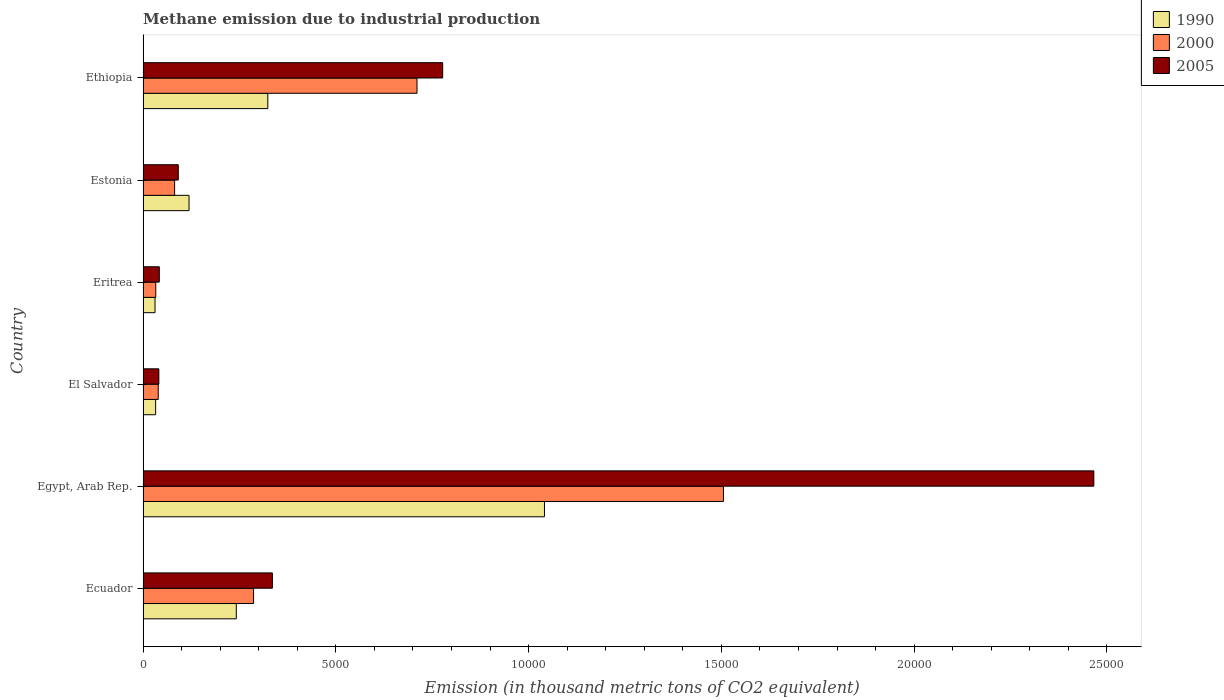How many different coloured bars are there?
Offer a very short reply. 3. Are the number of bars per tick equal to the number of legend labels?
Make the answer very short. Yes. Are the number of bars on each tick of the Y-axis equal?
Make the answer very short. Yes. How many bars are there on the 6th tick from the top?
Provide a short and direct response. 3. What is the label of the 6th group of bars from the top?
Offer a terse response. Ecuador. What is the amount of methane emitted in 2000 in Ethiopia?
Make the answer very short. 7106. Across all countries, what is the maximum amount of methane emitted in 2005?
Provide a succinct answer. 2.47e+04. Across all countries, what is the minimum amount of methane emitted in 2000?
Ensure brevity in your answer.  329.4. In which country was the amount of methane emitted in 2000 maximum?
Your response must be concise. Egypt, Arab Rep. In which country was the amount of methane emitted in 1990 minimum?
Offer a very short reply. Eritrea. What is the total amount of methane emitted in 2000 in the graph?
Offer a terse response. 2.66e+04. What is the difference between the amount of methane emitted in 2000 in Ecuador and that in Estonia?
Keep it short and to the point. 2047.9. What is the difference between the amount of methane emitted in 1990 in Eritrea and the amount of methane emitted in 2005 in Egypt, Arab Rep.?
Your response must be concise. -2.44e+04. What is the average amount of methane emitted in 1990 per country?
Offer a very short reply. 2982.55. What is the difference between the amount of methane emitted in 2000 and amount of methane emitted in 2005 in Egypt, Arab Rep.?
Offer a very short reply. -9607. What is the ratio of the amount of methane emitted in 2000 in El Salvador to that in Ethiopia?
Your answer should be very brief. 0.06. What is the difference between the highest and the second highest amount of methane emitted in 2005?
Make the answer very short. 1.69e+04. What is the difference between the highest and the lowest amount of methane emitted in 2000?
Your answer should be compact. 1.47e+04. What does the 3rd bar from the top in Eritrea represents?
Your response must be concise. 1990. What does the 3rd bar from the bottom in Ethiopia represents?
Ensure brevity in your answer.  2005. How many bars are there?
Your response must be concise. 18. Are all the bars in the graph horizontal?
Keep it short and to the point. Yes. How many countries are there in the graph?
Offer a very short reply. 6. Where does the legend appear in the graph?
Offer a terse response. Top right. How many legend labels are there?
Offer a terse response. 3. What is the title of the graph?
Your answer should be compact. Methane emission due to industrial production. Does "1973" appear as one of the legend labels in the graph?
Your answer should be compact. No. What is the label or title of the X-axis?
Provide a short and direct response. Emission (in thousand metric tons of CO2 equivalent). What is the label or title of the Y-axis?
Your answer should be compact. Country. What is the Emission (in thousand metric tons of CO2 equivalent) of 1990 in Ecuador?
Your response must be concise. 2418.4. What is the Emission (in thousand metric tons of CO2 equivalent) of 2000 in Ecuador?
Offer a terse response. 2866.1. What is the Emission (in thousand metric tons of CO2 equivalent) in 2005 in Ecuador?
Your response must be concise. 3354.7. What is the Emission (in thousand metric tons of CO2 equivalent) in 1990 in Egypt, Arab Rep.?
Your answer should be compact. 1.04e+04. What is the Emission (in thousand metric tons of CO2 equivalent) of 2000 in Egypt, Arab Rep.?
Give a very brief answer. 1.51e+04. What is the Emission (in thousand metric tons of CO2 equivalent) in 2005 in Egypt, Arab Rep.?
Your answer should be very brief. 2.47e+04. What is the Emission (in thousand metric tons of CO2 equivalent) of 1990 in El Salvador?
Make the answer very short. 325.8. What is the Emission (in thousand metric tons of CO2 equivalent) of 2000 in El Salvador?
Your answer should be very brief. 393.6. What is the Emission (in thousand metric tons of CO2 equivalent) in 2005 in El Salvador?
Provide a succinct answer. 409.3. What is the Emission (in thousand metric tons of CO2 equivalent) of 1990 in Eritrea?
Provide a short and direct response. 310.4. What is the Emission (in thousand metric tons of CO2 equivalent) of 2000 in Eritrea?
Offer a terse response. 329.4. What is the Emission (in thousand metric tons of CO2 equivalent) in 2005 in Eritrea?
Keep it short and to the point. 421.4. What is the Emission (in thousand metric tons of CO2 equivalent) in 1990 in Estonia?
Give a very brief answer. 1192.7. What is the Emission (in thousand metric tons of CO2 equivalent) in 2000 in Estonia?
Give a very brief answer. 818.2. What is the Emission (in thousand metric tons of CO2 equivalent) in 2005 in Estonia?
Your answer should be very brief. 913.5. What is the Emission (in thousand metric tons of CO2 equivalent) in 1990 in Ethiopia?
Your answer should be very brief. 3236. What is the Emission (in thousand metric tons of CO2 equivalent) of 2000 in Ethiopia?
Your answer should be compact. 7106. What is the Emission (in thousand metric tons of CO2 equivalent) of 2005 in Ethiopia?
Your response must be concise. 7772.1. Across all countries, what is the maximum Emission (in thousand metric tons of CO2 equivalent) in 1990?
Provide a short and direct response. 1.04e+04. Across all countries, what is the maximum Emission (in thousand metric tons of CO2 equivalent) in 2000?
Ensure brevity in your answer.  1.51e+04. Across all countries, what is the maximum Emission (in thousand metric tons of CO2 equivalent) in 2005?
Offer a very short reply. 2.47e+04. Across all countries, what is the minimum Emission (in thousand metric tons of CO2 equivalent) of 1990?
Give a very brief answer. 310.4. Across all countries, what is the minimum Emission (in thousand metric tons of CO2 equivalent) of 2000?
Your response must be concise. 329.4. Across all countries, what is the minimum Emission (in thousand metric tons of CO2 equivalent) of 2005?
Provide a short and direct response. 409.3. What is the total Emission (in thousand metric tons of CO2 equivalent) in 1990 in the graph?
Provide a succinct answer. 1.79e+04. What is the total Emission (in thousand metric tons of CO2 equivalent) in 2000 in the graph?
Keep it short and to the point. 2.66e+04. What is the total Emission (in thousand metric tons of CO2 equivalent) of 2005 in the graph?
Your answer should be very brief. 3.75e+04. What is the difference between the Emission (in thousand metric tons of CO2 equivalent) of 1990 in Ecuador and that in Egypt, Arab Rep.?
Offer a terse response. -7993.6. What is the difference between the Emission (in thousand metric tons of CO2 equivalent) of 2000 in Ecuador and that in Egypt, Arab Rep.?
Your answer should be compact. -1.22e+04. What is the difference between the Emission (in thousand metric tons of CO2 equivalent) of 2005 in Ecuador and that in Egypt, Arab Rep.?
Make the answer very short. -2.13e+04. What is the difference between the Emission (in thousand metric tons of CO2 equivalent) of 1990 in Ecuador and that in El Salvador?
Offer a very short reply. 2092.6. What is the difference between the Emission (in thousand metric tons of CO2 equivalent) of 2000 in Ecuador and that in El Salvador?
Your answer should be compact. 2472.5. What is the difference between the Emission (in thousand metric tons of CO2 equivalent) in 2005 in Ecuador and that in El Salvador?
Keep it short and to the point. 2945.4. What is the difference between the Emission (in thousand metric tons of CO2 equivalent) of 1990 in Ecuador and that in Eritrea?
Keep it short and to the point. 2108. What is the difference between the Emission (in thousand metric tons of CO2 equivalent) of 2000 in Ecuador and that in Eritrea?
Keep it short and to the point. 2536.7. What is the difference between the Emission (in thousand metric tons of CO2 equivalent) in 2005 in Ecuador and that in Eritrea?
Your response must be concise. 2933.3. What is the difference between the Emission (in thousand metric tons of CO2 equivalent) in 1990 in Ecuador and that in Estonia?
Your answer should be very brief. 1225.7. What is the difference between the Emission (in thousand metric tons of CO2 equivalent) in 2000 in Ecuador and that in Estonia?
Provide a succinct answer. 2047.9. What is the difference between the Emission (in thousand metric tons of CO2 equivalent) in 2005 in Ecuador and that in Estonia?
Ensure brevity in your answer.  2441.2. What is the difference between the Emission (in thousand metric tons of CO2 equivalent) in 1990 in Ecuador and that in Ethiopia?
Your answer should be very brief. -817.6. What is the difference between the Emission (in thousand metric tons of CO2 equivalent) in 2000 in Ecuador and that in Ethiopia?
Offer a very short reply. -4239.9. What is the difference between the Emission (in thousand metric tons of CO2 equivalent) in 2005 in Ecuador and that in Ethiopia?
Your answer should be compact. -4417.4. What is the difference between the Emission (in thousand metric tons of CO2 equivalent) of 1990 in Egypt, Arab Rep. and that in El Salvador?
Your answer should be very brief. 1.01e+04. What is the difference between the Emission (in thousand metric tons of CO2 equivalent) of 2000 in Egypt, Arab Rep. and that in El Salvador?
Your response must be concise. 1.47e+04. What is the difference between the Emission (in thousand metric tons of CO2 equivalent) of 2005 in Egypt, Arab Rep. and that in El Salvador?
Your answer should be very brief. 2.43e+04. What is the difference between the Emission (in thousand metric tons of CO2 equivalent) in 1990 in Egypt, Arab Rep. and that in Eritrea?
Keep it short and to the point. 1.01e+04. What is the difference between the Emission (in thousand metric tons of CO2 equivalent) in 2000 in Egypt, Arab Rep. and that in Eritrea?
Ensure brevity in your answer.  1.47e+04. What is the difference between the Emission (in thousand metric tons of CO2 equivalent) of 2005 in Egypt, Arab Rep. and that in Eritrea?
Your answer should be very brief. 2.42e+04. What is the difference between the Emission (in thousand metric tons of CO2 equivalent) in 1990 in Egypt, Arab Rep. and that in Estonia?
Offer a very short reply. 9219.3. What is the difference between the Emission (in thousand metric tons of CO2 equivalent) in 2000 in Egypt, Arab Rep. and that in Estonia?
Your answer should be compact. 1.42e+04. What is the difference between the Emission (in thousand metric tons of CO2 equivalent) of 2005 in Egypt, Arab Rep. and that in Estonia?
Give a very brief answer. 2.37e+04. What is the difference between the Emission (in thousand metric tons of CO2 equivalent) in 1990 in Egypt, Arab Rep. and that in Ethiopia?
Ensure brevity in your answer.  7176. What is the difference between the Emission (in thousand metric tons of CO2 equivalent) in 2000 in Egypt, Arab Rep. and that in Ethiopia?
Your answer should be compact. 7948.9. What is the difference between the Emission (in thousand metric tons of CO2 equivalent) of 2005 in Egypt, Arab Rep. and that in Ethiopia?
Your response must be concise. 1.69e+04. What is the difference between the Emission (in thousand metric tons of CO2 equivalent) of 2000 in El Salvador and that in Eritrea?
Your answer should be compact. 64.2. What is the difference between the Emission (in thousand metric tons of CO2 equivalent) in 2005 in El Salvador and that in Eritrea?
Keep it short and to the point. -12.1. What is the difference between the Emission (in thousand metric tons of CO2 equivalent) of 1990 in El Salvador and that in Estonia?
Your response must be concise. -866.9. What is the difference between the Emission (in thousand metric tons of CO2 equivalent) in 2000 in El Salvador and that in Estonia?
Your answer should be very brief. -424.6. What is the difference between the Emission (in thousand metric tons of CO2 equivalent) of 2005 in El Salvador and that in Estonia?
Provide a short and direct response. -504.2. What is the difference between the Emission (in thousand metric tons of CO2 equivalent) of 1990 in El Salvador and that in Ethiopia?
Ensure brevity in your answer.  -2910.2. What is the difference between the Emission (in thousand metric tons of CO2 equivalent) of 2000 in El Salvador and that in Ethiopia?
Ensure brevity in your answer.  -6712.4. What is the difference between the Emission (in thousand metric tons of CO2 equivalent) of 2005 in El Salvador and that in Ethiopia?
Make the answer very short. -7362.8. What is the difference between the Emission (in thousand metric tons of CO2 equivalent) of 1990 in Eritrea and that in Estonia?
Your response must be concise. -882.3. What is the difference between the Emission (in thousand metric tons of CO2 equivalent) in 2000 in Eritrea and that in Estonia?
Give a very brief answer. -488.8. What is the difference between the Emission (in thousand metric tons of CO2 equivalent) of 2005 in Eritrea and that in Estonia?
Offer a terse response. -492.1. What is the difference between the Emission (in thousand metric tons of CO2 equivalent) in 1990 in Eritrea and that in Ethiopia?
Ensure brevity in your answer.  -2925.6. What is the difference between the Emission (in thousand metric tons of CO2 equivalent) in 2000 in Eritrea and that in Ethiopia?
Provide a short and direct response. -6776.6. What is the difference between the Emission (in thousand metric tons of CO2 equivalent) in 2005 in Eritrea and that in Ethiopia?
Offer a terse response. -7350.7. What is the difference between the Emission (in thousand metric tons of CO2 equivalent) of 1990 in Estonia and that in Ethiopia?
Your response must be concise. -2043.3. What is the difference between the Emission (in thousand metric tons of CO2 equivalent) of 2000 in Estonia and that in Ethiopia?
Keep it short and to the point. -6287.8. What is the difference between the Emission (in thousand metric tons of CO2 equivalent) in 2005 in Estonia and that in Ethiopia?
Offer a very short reply. -6858.6. What is the difference between the Emission (in thousand metric tons of CO2 equivalent) of 1990 in Ecuador and the Emission (in thousand metric tons of CO2 equivalent) of 2000 in Egypt, Arab Rep.?
Your answer should be compact. -1.26e+04. What is the difference between the Emission (in thousand metric tons of CO2 equivalent) in 1990 in Ecuador and the Emission (in thousand metric tons of CO2 equivalent) in 2005 in Egypt, Arab Rep.?
Make the answer very short. -2.22e+04. What is the difference between the Emission (in thousand metric tons of CO2 equivalent) in 2000 in Ecuador and the Emission (in thousand metric tons of CO2 equivalent) in 2005 in Egypt, Arab Rep.?
Provide a short and direct response. -2.18e+04. What is the difference between the Emission (in thousand metric tons of CO2 equivalent) of 1990 in Ecuador and the Emission (in thousand metric tons of CO2 equivalent) of 2000 in El Salvador?
Ensure brevity in your answer.  2024.8. What is the difference between the Emission (in thousand metric tons of CO2 equivalent) of 1990 in Ecuador and the Emission (in thousand metric tons of CO2 equivalent) of 2005 in El Salvador?
Keep it short and to the point. 2009.1. What is the difference between the Emission (in thousand metric tons of CO2 equivalent) in 2000 in Ecuador and the Emission (in thousand metric tons of CO2 equivalent) in 2005 in El Salvador?
Offer a very short reply. 2456.8. What is the difference between the Emission (in thousand metric tons of CO2 equivalent) in 1990 in Ecuador and the Emission (in thousand metric tons of CO2 equivalent) in 2000 in Eritrea?
Provide a succinct answer. 2089. What is the difference between the Emission (in thousand metric tons of CO2 equivalent) in 1990 in Ecuador and the Emission (in thousand metric tons of CO2 equivalent) in 2005 in Eritrea?
Provide a succinct answer. 1997. What is the difference between the Emission (in thousand metric tons of CO2 equivalent) of 2000 in Ecuador and the Emission (in thousand metric tons of CO2 equivalent) of 2005 in Eritrea?
Ensure brevity in your answer.  2444.7. What is the difference between the Emission (in thousand metric tons of CO2 equivalent) of 1990 in Ecuador and the Emission (in thousand metric tons of CO2 equivalent) of 2000 in Estonia?
Offer a very short reply. 1600.2. What is the difference between the Emission (in thousand metric tons of CO2 equivalent) of 1990 in Ecuador and the Emission (in thousand metric tons of CO2 equivalent) of 2005 in Estonia?
Your response must be concise. 1504.9. What is the difference between the Emission (in thousand metric tons of CO2 equivalent) of 2000 in Ecuador and the Emission (in thousand metric tons of CO2 equivalent) of 2005 in Estonia?
Provide a short and direct response. 1952.6. What is the difference between the Emission (in thousand metric tons of CO2 equivalent) of 1990 in Ecuador and the Emission (in thousand metric tons of CO2 equivalent) of 2000 in Ethiopia?
Offer a very short reply. -4687.6. What is the difference between the Emission (in thousand metric tons of CO2 equivalent) in 1990 in Ecuador and the Emission (in thousand metric tons of CO2 equivalent) in 2005 in Ethiopia?
Offer a very short reply. -5353.7. What is the difference between the Emission (in thousand metric tons of CO2 equivalent) of 2000 in Ecuador and the Emission (in thousand metric tons of CO2 equivalent) of 2005 in Ethiopia?
Offer a very short reply. -4906. What is the difference between the Emission (in thousand metric tons of CO2 equivalent) of 1990 in Egypt, Arab Rep. and the Emission (in thousand metric tons of CO2 equivalent) of 2000 in El Salvador?
Your answer should be compact. 1.00e+04. What is the difference between the Emission (in thousand metric tons of CO2 equivalent) in 1990 in Egypt, Arab Rep. and the Emission (in thousand metric tons of CO2 equivalent) in 2005 in El Salvador?
Offer a terse response. 1.00e+04. What is the difference between the Emission (in thousand metric tons of CO2 equivalent) in 2000 in Egypt, Arab Rep. and the Emission (in thousand metric tons of CO2 equivalent) in 2005 in El Salvador?
Your answer should be very brief. 1.46e+04. What is the difference between the Emission (in thousand metric tons of CO2 equivalent) of 1990 in Egypt, Arab Rep. and the Emission (in thousand metric tons of CO2 equivalent) of 2000 in Eritrea?
Make the answer very short. 1.01e+04. What is the difference between the Emission (in thousand metric tons of CO2 equivalent) of 1990 in Egypt, Arab Rep. and the Emission (in thousand metric tons of CO2 equivalent) of 2005 in Eritrea?
Offer a very short reply. 9990.6. What is the difference between the Emission (in thousand metric tons of CO2 equivalent) in 2000 in Egypt, Arab Rep. and the Emission (in thousand metric tons of CO2 equivalent) in 2005 in Eritrea?
Your answer should be very brief. 1.46e+04. What is the difference between the Emission (in thousand metric tons of CO2 equivalent) of 1990 in Egypt, Arab Rep. and the Emission (in thousand metric tons of CO2 equivalent) of 2000 in Estonia?
Keep it short and to the point. 9593.8. What is the difference between the Emission (in thousand metric tons of CO2 equivalent) of 1990 in Egypt, Arab Rep. and the Emission (in thousand metric tons of CO2 equivalent) of 2005 in Estonia?
Offer a terse response. 9498.5. What is the difference between the Emission (in thousand metric tons of CO2 equivalent) of 2000 in Egypt, Arab Rep. and the Emission (in thousand metric tons of CO2 equivalent) of 2005 in Estonia?
Provide a short and direct response. 1.41e+04. What is the difference between the Emission (in thousand metric tons of CO2 equivalent) in 1990 in Egypt, Arab Rep. and the Emission (in thousand metric tons of CO2 equivalent) in 2000 in Ethiopia?
Offer a very short reply. 3306. What is the difference between the Emission (in thousand metric tons of CO2 equivalent) of 1990 in Egypt, Arab Rep. and the Emission (in thousand metric tons of CO2 equivalent) of 2005 in Ethiopia?
Your answer should be compact. 2639.9. What is the difference between the Emission (in thousand metric tons of CO2 equivalent) of 2000 in Egypt, Arab Rep. and the Emission (in thousand metric tons of CO2 equivalent) of 2005 in Ethiopia?
Your answer should be compact. 7282.8. What is the difference between the Emission (in thousand metric tons of CO2 equivalent) in 1990 in El Salvador and the Emission (in thousand metric tons of CO2 equivalent) in 2000 in Eritrea?
Your response must be concise. -3.6. What is the difference between the Emission (in thousand metric tons of CO2 equivalent) in 1990 in El Salvador and the Emission (in thousand metric tons of CO2 equivalent) in 2005 in Eritrea?
Ensure brevity in your answer.  -95.6. What is the difference between the Emission (in thousand metric tons of CO2 equivalent) of 2000 in El Salvador and the Emission (in thousand metric tons of CO2 equivalent) of 2005 in Eritrea?
Give a very brief answer. -27.8. What is the difference between the Emission (in thousand metric tons of CO2 equivalent) in 1990 in El Salvador and the Emission (in thousand metric tons of CO2 equivalent) in 2000 in Estonia?
Your response must be concise. -492.4. What is the difference between the Emission (in thousand metric tons of CO2 equivalent) of 1990 in El Salvador and the Emission (in thousand metric tons of CO2 equivalent) of 2005 in Estonia?
Make the answer very short. -587.7. What is the difference between the Emission (in thousand metric tons of CO2 equivalent) in 2000 in El Salvador and the Emission (in thousand metric tons of CO2 equivalent) in 2005 in Estonia?
Provide a succinct answer. -519.9. What is the difference between the Emission (in thousand metric tons of CO2 equivalent) of 1990 in El Salvador and the Emission (in thousand metric tons of CO2 equivalent) of 2000 in Ethiopia?
Give a very brief answer. -6780.2. What is the difference between the Emission (in thousand metric tons of CO2 equivalent) of 1990 in El Salvador and the Emission (in thousand metric tons of CO2 equivalent) of 2005 in Ethiopia?
Ensure brevity in your answer.  -7446.3. What is the difference between the Emission (in thousand metric tons of CO2 equivalent) of 2000 in El Salvador and the Emission (in thousand metric tons of CO2 equivalent) of 2005 in Ethiopia?
Your answer should be compact. -7378.5. What is the difference between the Emission (in thousand metric tons of CO2 equivalent) in 1990 in Eritrea and the Emission (in thousand metric tons of CO2 equivalent) in 2000 in Estonia?
Provide a short and direct response. -507.8. What is the difference between the Emission (in thousand metric tons of CO2 equivalent) of 1990 in Eritrea and the Emission (in thousand metric tons of CO2 equivalent) of 2005 in Estonia?
Offer a terse response. -603.1. What is the difference between the Emission (in thousand metric tons of CO2 equivalent) of 2000 in Eritrea and the Emission (in thousand metric tons of CO2 equivalent) of 2005 in Estonia?
Your answer should be compact. -584.1. What is the difference between the Emission (in thousand metric tons of CO2 equivalent) in 1990 in Eritrea and the Emission (in thousand metric tons of CO2 equivalent) in 2000 in Ethiopia?
Your response must be concise. -6795.6. What is the difference between the Emission (in thousand metric tons of CO2 equivalent) in 1990 in Eritrea and the Emission (in thousand metric tons of CO2 equivalent) in 2005 in Ethiopia?
Your response must be concise. -7461.7. What is the difference between the Emission (in thousand metric tons of CO2 equivalent) of 2000 in Eritrea and the Emission (in thousand metric tons of CO2 equivalent) of 2005 in Ethiopia?
Offer a very short reply. -7442.7. What is the difference between the Emission (in thousand metric tons of CO2 equivalent) in 1990 in Estonia and the Emission (in thousand metric tons of CO2 equivalent) in 2000 in Ethiopia?
Your response must be concise. -5913.3. What is the difference between the Emission (in thousand metric tons of CO2 equivalent) in 1990 in Estonia and the Emission (in thousand metric tons of CO2 equivalent) in 2005 in Ethiopia?
Your response must be concise. -6579.4. What is the difference between the Emission (in thousand metric tons of CO2 equivalent) in 2000 in Estonia and the Emission (in thousand metric tons of CO2 equivalent) in 2005 in Ethiopia?
Offer a terse response. -6953.9. What is the average Emission (in thousand metric tons of CO2 equivalent) of 1990 per country?
Your answer should be very brief. 2982.55. What is the average Emission (in thousand metric tons of CO2 equivalent) in 2000 per country?
Provide a succinct answer. 4428.03. What is the average Emission (in thousand metric tons of CO2 equivalent) of 2005 per country?
Give a very brief answer. 6255.48. What is the difference between the Emission (in thousand metric tons of CO2 equivalent) in 1990 and Emission (in thousand metric tons of CO2 equivalent) in 2000 in Ecuador?
Your response must be concise. -447.7. What is the difference between the Emission (in thousand metric tons of CO2 equivalent) of 1990 and Emission (in thousand metric tons of CO2 equivalent) of 2005 in Ecuador?
Ensure brevity in your answer.  -936.3. What is the difference between the Emission (in thousand metric tons of CO2 equivalent) in 2000 and Emission (in thousand metric tons of CO2 equivalent) in 2005 in Ecuador?
Your answer should be compact. -488.6. What is the difference between the Emission (in thousand metric tons of CO2 equivalent) in 1990 and Emission (in thousand metric tons of CO2 equivalent) in 2000 in Egypt, Arab Rep.?
Provide a short and direct response. -4642.9. What is the difference between the Emission (in thousand metric tons of CO2 equivalent) of 1990 and Emission (in thousand metric tons of CO2 equivalent) of 2005 in Egypt, Arab Rep.?
Provide a short and direct response. -1.42e+04. What is the difference between the Emission (in thousand metric tons of CO2 equivalent) of 2000 and Emission (in thousand metric tons of CO2 equivalent) of 2005 in Egypt, Arab Rep.?
Give a very brief answer. -9607. What is the difference between the Emission (in thousand metric tons of CO2 equivalent) in 1990 and Emission (in thousand metric tons of CO2 equivalent) in 2000 in El Salvador?
Offer a terse response. -67.8. What is the difference between the Emission (in thousand metric tons of CO2 equivalent) in 1990 and Emission (in thousand metric tons of CO2 equivalent) in 2005 in El Salvador?
Provide a succinct answer. -83.5. What is the difference between the Emission (in thousand metric tons of CO2 equivalent) of 2000 and Emission (in thousand metric tons of CO2 equivalent) of 2005 in El Salvador?
Keep it short and to the point. -15.7. What is the difference between the Emission (in thousand metric tons of CO2 equivalent) in 1990 and Emission (in thousand metric tons of CO2 equivalent) in 2005 in Eritrea?
Offer a terse response. -111. What is the difference between the Emission (in thousand metric tons of CO2 equivalent) of 2000 and Emission (in thousand metric tons of CO2 equivalent) of 2005 in Eritrea?
Provide a short and direct response. -92. What is the difference between the Emission (in thousand metric tons of CO2 equivalent) of 1990 and Emission (in thousand metric tons of CO2 equivalent) of 2000 in Estonia?
Your answer should be compact. 374.5. What is the difference between the Emission (in thousand metric tons of CO2 equivalent) in 1990 and Emission (in thousand metric tons of CO2 equivalent) in 2005 in Estonia?
Your response must be concise. 279.2. What is the difference between the Emission (in thousand metric tons of CO2 equivalent) in 2000 and Emission (in thousand metric tons of CO2 equivalent) in 2005 in Estonia?
Your answer should be very brief. -95.3. What is the difference between the Emission (in thousand metric tons of CO2 equivalent) of 1990 and Emission (in thousand metric tons of CO2 equivalent) of 2000 in Ethiopia?
Offer a terse response. -3870. What is the difference between the Emission (in thousand metric tons of CO2 equivalent) of 1990 and Emission (in thousand metric tons of CO2 equivalent) of 2005 in Ethiopia?
Offer a very short reply. -4536.1. What is the difference between the Emission (in thousand metric tons of CO2 equivalent) in 2000 and Emission (in thousand metric tons of CO2 equivalent) in 2005 in Ethiopia?
Your answer should be very brief. -666.1. What is the ratio of the Emission (in thousand metric tons of CO2 equivalent) in 1990 in Ecuador to that in Egypt, Arab Rep.?
Give a very brief answer. 0.23. What is the ratio of the Emission (in thousand metric tons of CO2 equivalent) in 2000 in Ecuador to that in Egypt, Arab Rep.?
Provide a succinct answer. 0.19. What is the ratio of the Emission (in thousand metric tons of CO2 equivalent) in 2005 in Ecuador to that in Egypt, Arab Rep.?
Your answer should be very brief. 0.14. What is the ratio of the Emission (in thousand metric tons of CO2 equivalent) in 1990 in Ecuador to that in El Salvador?
Make the answer very short. 7.42. What is the ratio of the Emission (in thousand metric tons of CO2 equivalent) in 2000 in Ecuador to that in El Salvador?
Offer a terse response. 7.28. What is the ratio of the Emission (in thousand metric tons of CO2 equivalent) in 2005 in Ecuador to that in El Salvador?
Keep it short and to the point. 8.2. What is the ratio of the Emission (in thousand metric tons of CO2 equivalent) of 1990 in Ecuador to that in Eritrea?
Make the answer very short. 7.79. What is the ratio of the Emission (in thousand metric tons of CO2 equivalent) in 2000 in Ecuador to that in Eritrea?
Keep it short and to the point. 8.7. What is the ratio of the Emission (in thousand metric tons of CO2 equivalent) in 2005 in Ecuador to that in Eritrea?
Offer a very short reply. 7.96. What is the ratio of the Emission (in thousand metric tons of CO2 equivalent) in 1990 in Ecuador to that in Estonia?
Make the answer very short. 2.03. What is the ratio of the Emission (in thousand metric tons of CO2 equivalent) in 2000 in Ecuador to that in Estonia?
Give a very brief answer. 3.5. What is the ratio of the Emission (in thousand metric tons of CO2 equivalent) of 2005 in Ecuador to that in Estonia?
Provide a succinct answer. 3.67. What is the ratio of the Emission (in thousand metric tons of CO2 equivalent) in 1990 in Ecuador to that in Ethiopia?
Offer a terse response. 0.75. What is the ratio of the Emission (in thousand metric tons of CO2 equivalent) in 2000 in Ecuador to that in Ethiopia?
Provide a short and direct response. 0.4. What is the ratio of the Emission (in thousand metric tons of CO2 equivalent) of 2005 in Ecuador to that in Ethiopia?
Ensure brevity in your answer.  0.43. What is the ratio of the Emission (in thousand metric tons of CO2 equivalent) in 1990 in Egypt, Arab Rep. to that in El Salvador?
Make the answer very short. 31.96. What is the ratio of the Emission (in thousand metric tons of CO2 equivalent) in 2000 in Egypt, Arab Rep. to that in El Salvador?
Offer a terse response. 38.25. What is the ratio of the Emission (in thousand metric tons of CO2 equivalent) in 2005 in Egypt, Arab Rep. to that in El Salvador?
Your answer should be very brief. 60.25. What is the ratio of the Emission (in thousand metric tons of CO2 equivalent) in 1990 in Egypt, Arab Rep. to that in Eritrea?
Your answer should be compact. 33.54. What is the ratio of the Emission (in thousand metric tons of CO2 equivalent) of 2000 in Egypt, Arab Rep. to that in Eritrea?
Your answer should be very brief. 45.7. What is the ratio of the Emission (in thousand metric tons of CO2 equivalent) of 2005 in Egypt, Arab Rep. to that in Eritrea?
Keep it short and to the point. 58.52. What is the ratio of the Emission (in thousand metric tons of CO2 equivalent) of 1990 in Egypt, Arab Rep. to that in Estonia?
Offer a terse response. 8.73. What is the ratio of the Emission (in thousand metric tons of CO2 equivalent) of 2005 in Egypt, Arab Rep. to that in Estonia?
Your response must be concise. 27. What is the ratio of the Emission (in thousand metric tons of CO2 equivalent) of 1990 in Egypt, Arab Rep. to that in Ethiopia?
Keep it short and to the point. 3.22. What is the ratio of the Emission (in thousand metric tons of CO2 equivalent) in 2000 in Egypt, Arab Rep. to that in Ethiopia?
Give a very brief answer. 2.12. What is the ratio of the Emission (in thousand metric tons of CO2 equivalent) of 2005 in Egypt, Arab Rep. to that in Ethiopia?
Offer a very short reply. 3.17. What is the ratio of the Emission (in thousand metric tons of CO2 equivalent) of 1990 in El Salvador to that in Eritrea?
Provide a succinct answer. 1.05. What is the ratio of the Emission (in thousand metric tons of CO2 equivalent) in 2000 in El Salvador to that in Eritrea?
Your answer should be very brief. 1.19. What is the ratio of the Emission (in thousand metric tons of CO2 equivalent) of 2005 in El Salvador to that in Eritrea?
Your response must be concise. 0.97. What is the ratio of the Emission (in thousand metric tons of CO2 equivalent) of 1990 in El Salvador to that in Estonia?
Your answer should be very brief. 0.27. What is the ratio of the Emission (in thousand metric tons of CO2 equivalent) of 2000 in El Salvador to that in Estonia?
Offer a very short reply. 0.48. What is the ratio of the Emission (in thousand metric tons of CO2 equivalent) in 2005 in El Salvador to that in Estonia?
Make the answer very short. 0.45. What is the ratio of the Emission (in thousand metric tons of CO2 equivalent) of 1990 in El Salvador to that in Ethiopia?
Ensure brevity in your answer.  0.1. What is the ratio of the Emission (in thousand metric tons of CO2 equivalent) of 2000 in El Salvador to that in Ethiopia?
Offer a very short reply. 0.06. What is the ratio of the Emission (in thousand metric tons of CO2 equivalent) of 2005 in El Salvador to that in Ethiopia?
Keep it short and to the point. 0.05. What is the ratio of the Emission (in thousand metric tons of CO2 equivalent) of 1990 in Eritrea to that in Estonia?
Keep it short and to the point. 0.26. What is the ratio of the Emission (in thousand metric tons of CO2 equivalent) in 2000 in Eritrea to that in Estonia?
Provide a short and direct response. 0.4. What is the ratio of the Emission (in thousand metric tons of CO2 equivalent) of 2005 in Eritrea to that in Estonia?
Make the answer very short. 0.46. What is the ratio of the Emission (in thousand metric tons of CO2 equivalent) in 1990 in Eritrea to that in Ethiopia?
Make the answer very short. 0.1. What is the ratio of the Emission (in thousand metric tons of CO2 equivalent) of 2000 in Eritrea to that in Ethiopia?
Your response must be concise. 0.05. What is the ratio of the Emission (in thousand metric tons of CO2 equivalent) of 2005 in Eritrea to that in Ethiopia?
Make the answer very short. 0.05. What is the ratio of the Emission (in thousand metric tons of CO2 equivalent) in 1990 in Estonia to that in Ethiopia?
Your answer should be compact. 0.37. What is the ratio of the Emission (in thousand metric tons of CO2 equivalent) of 2000 in Estonia to that in Ethiopia?
Your response must be concise. 0.12. What is the ratio of the Emission (in thousand metric tons of CO2 equivalent) in 2005 in Estonia to that in Ethiopia?
Keep it short and to the point. 0.12. What is the difference between the highest and the second highest Emission (in thousand metric tons of CO2 equivalent) of 1990?
Keep it short and to the point. 7176. What is the difference between the highest and the second highest Emission (in thousand metric tons of CO2 equivalent) of 2000?
Your answer should be compact. 7948.9. What is the difference between the highest and the second highest Emission (in thousand metric tons of CO2 equivalent) in 2005?
Provide a succinct answer. 1.69e+04. What is the difference between the highest and the lowest Emission (in thousand metric tons of CO2 equivalent) in 1990?
Give a very brief answer. 1.01e+04. What is the difference between the highest and the lowest Emission (in thousand metric tons of CO2 equivalent) in 2000?
Offer a very short reply. 1.47e+04. What is the difference between the highest and the lowest Emission (in thousand metric tons of CO2 equivalent) in 2005?
Offer a very short reply. 2.43e+04. 